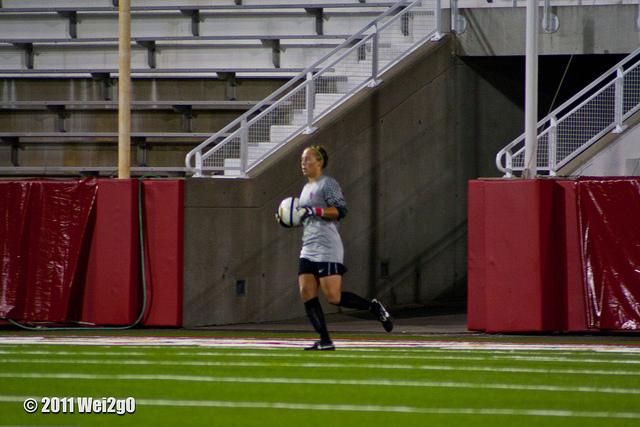What race is the child in the photo?
Write a very short answer. White. What sport is this person playing?
Concise answer only. Soccer. What sport is she playing?
Answer briefly. Soccer. Is anyone watching the game?
Give a very brief answer. No. 